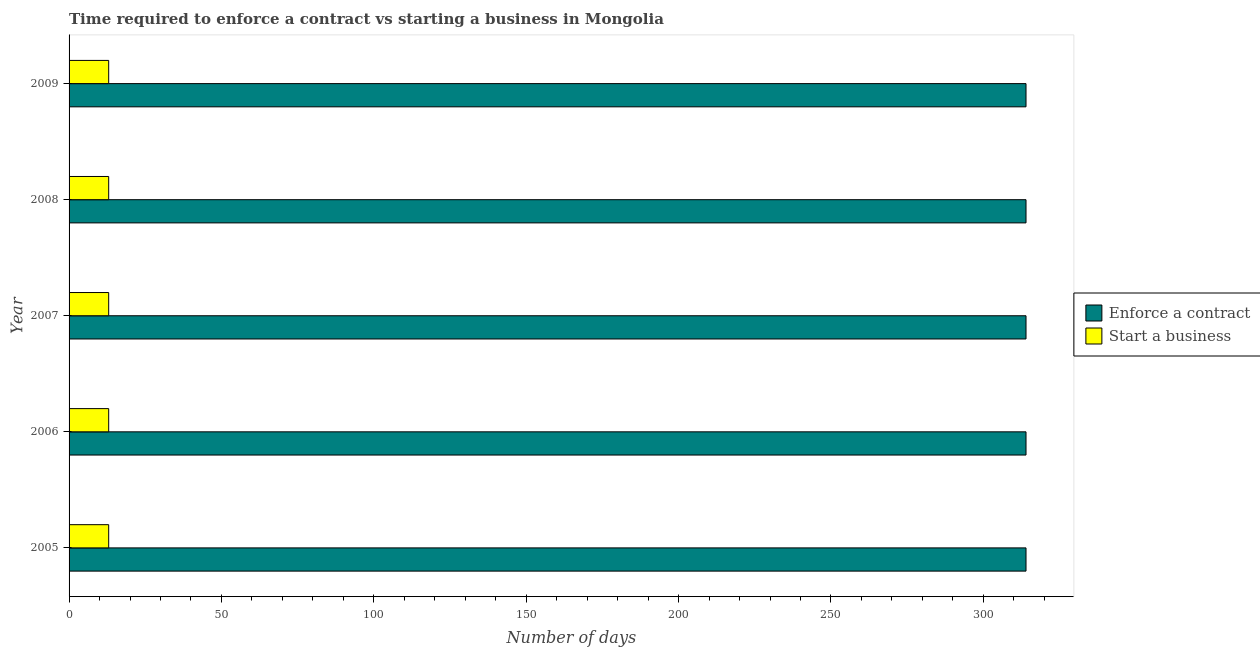How many different coloured bars are there?
Keep it short and to the point. 2. Are the number of bars on each tick of the Y-axis equal?
Offer a very short reply. Yes. How many bars are there on the 1st tick from the top?
Give a very brief answer. 2. How many bars are there on the 4th tick from the bottom?
Provide a succinct answer. 2. What is the label of the 5th group of bars from the top?
Provide a short and direct response. 2005. In how many cases, is the number of bars for a given year not equal to the number of legend labels?
Keep it short and to the point. 0. What is the number of days to enforece a contract in 2007?
Your response must be concise. 314. Across all years, what is the maximum number of days to enforece a contract?
Offer a very short reply. 314. Across all years, what is the minimum number of days to enforece a contract?
Provide a succinct answer. 314. What is the total number of days to start a business in the graph?
Offer a terse response. 65. What is the difference between the number of days to start a business in 2005 and that in 2009?
Offer a very short reply. 0. What is the difference between the number of days to enforece a contract in 2005 and the number of days to start a business in 2007?
Give a very brief answer. 301. What is the average number of days to enforece a contract per year?
Offer a terse response. 314. In the year 2005, what is the difference between the number of days to enforece a contract and number of days to start a business?
Your response must be concise. 301. What is the ratio of the number of days to enforece a contract in 2006 to that in 2007?
Keep it short and to the point. 1. Is the difference between the number of days to start a business in 2005 and 2007 greater than the difference between the number of days to enforece a contract in 2005 and 2007?
Offer a very short reply. No. What is the difference between the highest and the lowest number of days to enforece a contract?
Your answer should be compact. 0. In how many years, is the number of days to start a business greater than the average number of days to start a business taken over all years?
Ensure brevity in your answer.  0. What does the 2nd bar from the top in 2009 represents?
Ensure brevity in your answer.  Enforce a contract. What does the 2nd bar from the bottom in 2008 represents?
Your answer should be very brief. Start a business. How many bars are there?
Offer a terse response. 10. What is the difference between two consecutive major ticks on the X-axis?
Your answer should be very brief. 50. Are the values on the major ticks of X-axis written in scientific E-notation?
Ensure brevity in your answer.  No. Does the graph contain grids?
Provide a short and direct response. No. Where does the legend appear in the graph?
Your answer should be very brief. Center right. How many legend labels are there?
Provide a short and direct response. 2. What is the title of the graph?
Provide a succinct answer. Time required to enforce a contract vs starting a business in Mongolia. Does "Registered firms" appear as one of the legend labels in the graph?
Your answer should be very brief. No. What is the label or title of the X-axis?
Give a very brief answer. Number of days. What is the label or title of the Y-axis?
Your response must be concise. Year. What is the Number of days of Enforce a contract in 2005?
Your answer should be very brief. 314. What is the Number of days in Enforce a contract in 2006?
Give a very brief answer. 314. What is the Number of days of Enforce a contract in 2007?
Your answer should be very brief. 314. What is the Number of days in Enforce a contract in 2008?
Offer a very short reply. 314. What is the Number of days of Start a business in 2008?
Make the answer very short. 13. What is the Number of days of Enforce a contract in 2009?
Provide a succinct answer. 314. Across all years, what is the maximum Number of days in Enforce a contract?
Offer a terse response. 314. Across all years, what is the maximum Number of days of Start a business?
Make the answer very short. 13. Across all years, what is the minimum Number of days of Enforce a contract?
Offer a very short reply. 314. What is the total Number of days of Enforce a contract in the graph?
Provide a succinct answer. 1570. What is the total Number of days in Start a business in the graph?
Keep it short and to the point. 65. What is the difference between the Number of days in Start a business in 2005 and that in 2008?
Give a very brief answer. 0. What is the difference between the Number of days in Enforce a contract in 2005 and that in 2009?
Provide a succinct answer. 0. What is the difference between the Number of days in Start a business in 2005 and that in 2009?
Your answer should be compact. 0. What is the difference between the Number of days in Enforce a contract in 2006 and that in 2007?
Offer a very short reply. 0. What is the difference between the Number of days of Enforce a contract in 2006 and that in 2008?
Provide a succinct answer. 0. What is the difference between the Number of days of Enforce a contract in 2007 and that in 2009?
Your answer should be very brief. 0. What is the difference between the Number of days of Enforce a contract in 2008 and that in 2009?
Your response must be concise. 0. What is the difference between the Number of days of Enforce a contract in 2005 and the Number of days of Start a business in 2006?
Keep it short and to the point. 301. What is the difference between the Number of days of Enforce a contract in 2005 and the Number of days of Start a business in 2007?
Offer a very short reply. 301. What is the difference between the Number of days in Enforce a contract in 2005 and the Number of days in Start a business in 2008?
Keep it short and to the point. 301. What is the difference between the Number of days in Enforce a contract in 2005 and the Number of days in Start a business in 2009?
Keep it short and to the point. 301. What is the difference between the Number of days in Enforce a contract in 2006 and the Number of days in Start a business in 2007?
Your answer should be compact. 301. What is the difference between the Number of days in Enforce a contract in 2006 and the Number of days in Start a business in 2008?
Provide a short and direct response. 301. What is the difference between the Number of days of Enforce a contract in 2006 and the Number of days of Start a business in 2009?
Give a very brief answer. 301. What is the difference between the Number of days in Enforce a contract in 2007 and the Number of days in Start a business in 2008?
Provide a short and direct response. 301. What is the difference between the Number of days in Enforce a contract in 2007 and the Number of days in Start a business in 2009?
Make the answer very short. 301. What is the difference between the Number of days of Enforce a contract in 2008 and the Number of days of Start a business in 2009?
Offer a very short reply. 301. What is the average Number of days of Enforce a contract per year?
Make the answer very short. 314. What is the average Number of days in Start a business per year?
Your response must be concise. 13. In the year 2005, what is the difference between the Number of days of Enforce a contract and Number of days of Start a business?
Offer a terse response. 301. In the year 2006, what is the difference between the Number of days in Enforce a contract and Number of days in Start a business?
Provide a short and direct response. 301. In the year 2007, what is the difference between the Number of days of Enforce a contract and Number of days of Start a business?
Make the answer very short. 301. In the year 2008, what is the difference between the Number of days of Enforce a contract and Number of days of Start a business?
Provide a succinct answer. 301. In the year 2009, what is the difference between the Number of days in Enforce a contract and Number of days in Start a business?
Your response must be concise. 301. What is the ratio of the Number of days of Enforce a contract in 2005 to that in 2006?
Your response must be concise. 1. What is the ratio of the Number of days in Start a business in 2005 to that in 2007?
Make the answer very short. 1. What is the ratio of the Number of days of Start a business in 2005 to that in 2008?
Your response must be concise. 1. What is the ratio of the Number of days of Enforce a contract in 2006 to that in 2007?
Offer a very short reply. 1. What is the ratio of the Number of days in Start a business in 2006 to that in 2007?
Your response must be concise. 1. What is the ratio of the Number of days of Enforce a contract in 2006 to that in 2008?
Give a very brief answer. 1. What is the ratio of the Number of days in Enforce a contract in 2006 to that in 2009?
Offer a very short reply. 1. What is the ratio of the Number of days in Start a business in 2007 to that in 2008?
Provide a short and direct response. 1. What is the ratio of the Number of days in Start a business in 2007 to that in 2009?
Offer a terse response. 1. What is the ratio of the Number of days in Enforce a contract in 2008 to that in 2009?
Your answer should be very brief. 1. What is the difference between the highest and the lowest Number of days of Start a business?
Offer a very short reply. 0. 